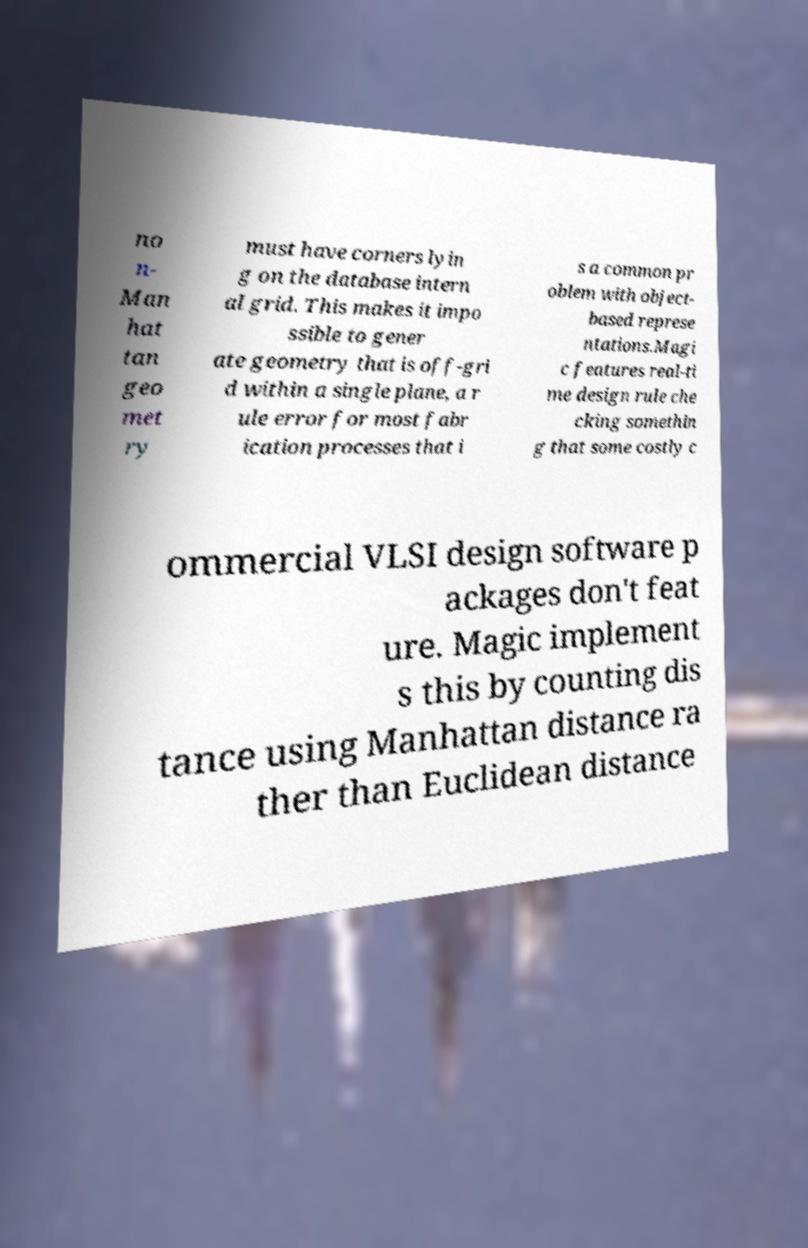There's text embedded in this image that I need extracted. Can you transcribe it verbatim? no n- Man hat tan geo met ry must have corners lyin g on the database intern al grid. This makes it impo ssible to gener ate geometry that is off-gri d within a single plane, a r ule error for most fabr ication processes that i s a common pr oblem with object- based represe ntations.Magi c features real-ti me design rule che cking somethin g that some costly c ommercial VLSI design software p ackages don't feat ure. Magic implement s this by counting dis tance using Manhattan distance ra ther than Euclidean distance 